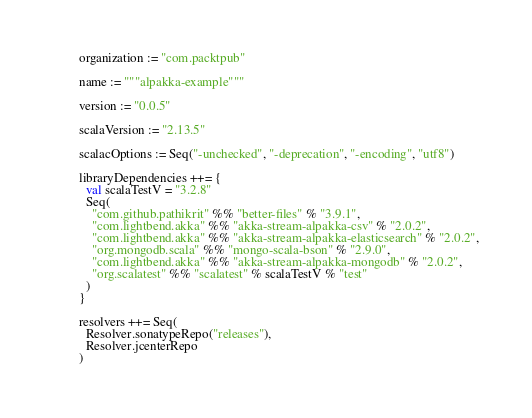Convert code to text. <code><loc_0><loc_0><loc_500><loc_500><_Scala_>organization := "com.packtpub"

name := """alpakka-example"""

version := "0.0.5"

scalaVersion := "2.13.5"

scalacOptions := Seq("-unchecked", "-deprecation", "-encoding", "utf8")

libraryDependencies ++= {
  val scalaTestV = "3.2.8"
  Seq(
    "com.github.pathikrit" %% "better-files" % "3.9.1",
    "com.lightbend.akka" %% "akka-stream-alpakka-csv" % "2.0.2",
    "com.lightbend.akka" %% "akka-stream-alpakka-elasticsearch" % "2.0.2",
    "org.mongodb.scala" %% "mongo-scala-bson" % "2.9.0",
    "com.lightbend.akka" %% "akka-stream-alpakka-mongodb" % "2.0.2",
    "org.scalatest" %% "scalatest" % scalaTestV % "test"
  )
}

resolvers ++= Seq(
  Resolver.sonatypeRepo("releases"),
  Resolver.jcenterRepo
)
</code> 